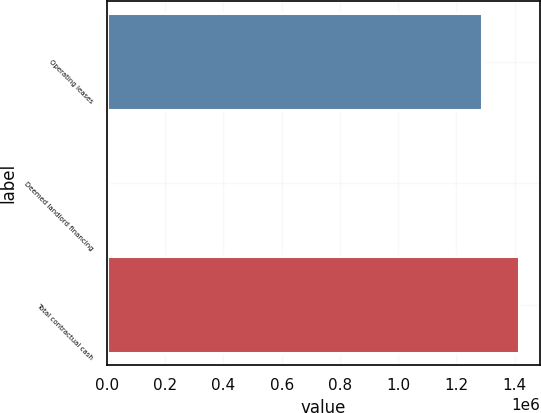Convert chart to OTSL. <chart><loc_0><loc_0><loc_500><loc_500><bar_chart><fcel>Operating leases<fcel>Deemed landlord financing<fcel>Total contractual cash<nl><fcel>1.28809e+06<fcel>4316<fcel>1.4169e+06<nl></chart> 